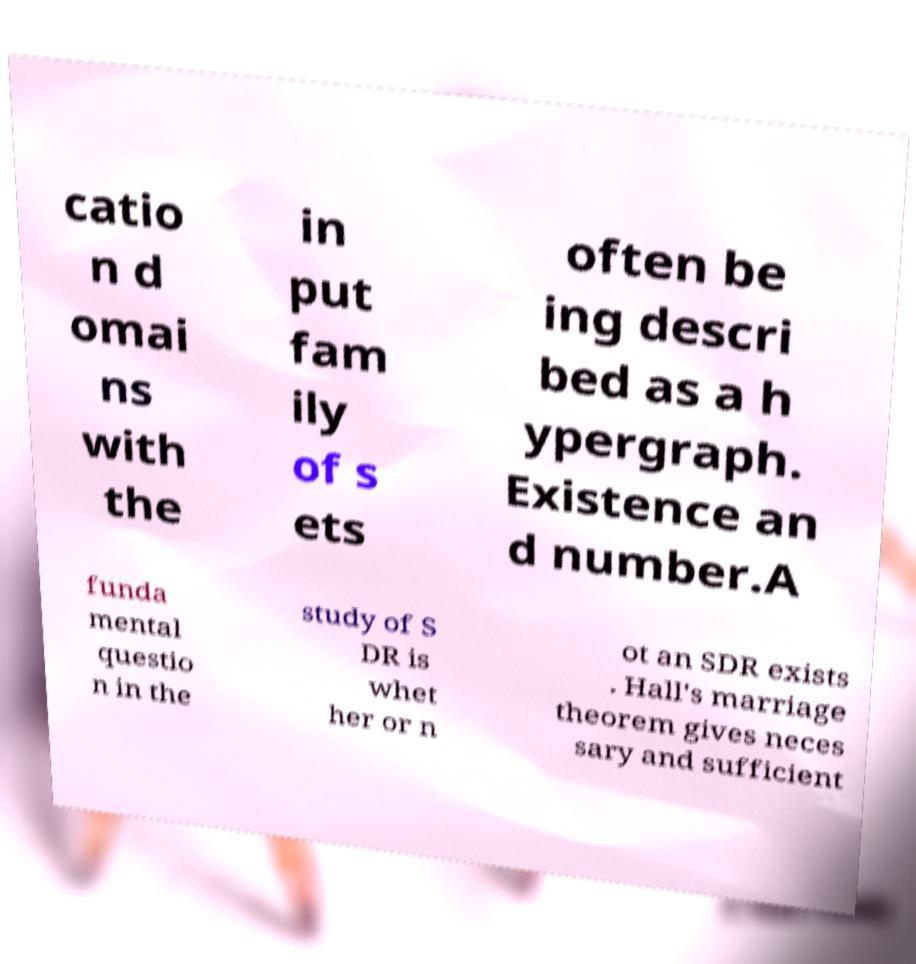What messages or text are displayed in this image? I need them in a readable, typed format. catio n d omai ns with the in put fam ily of s ets often be ing descri bed as a h ypergraph. Existence an d number.A funda mental questio n in the study of S DR is whet her or n ot an SDR exists . Hall's marriage theorem gives neces sary and sufficient 